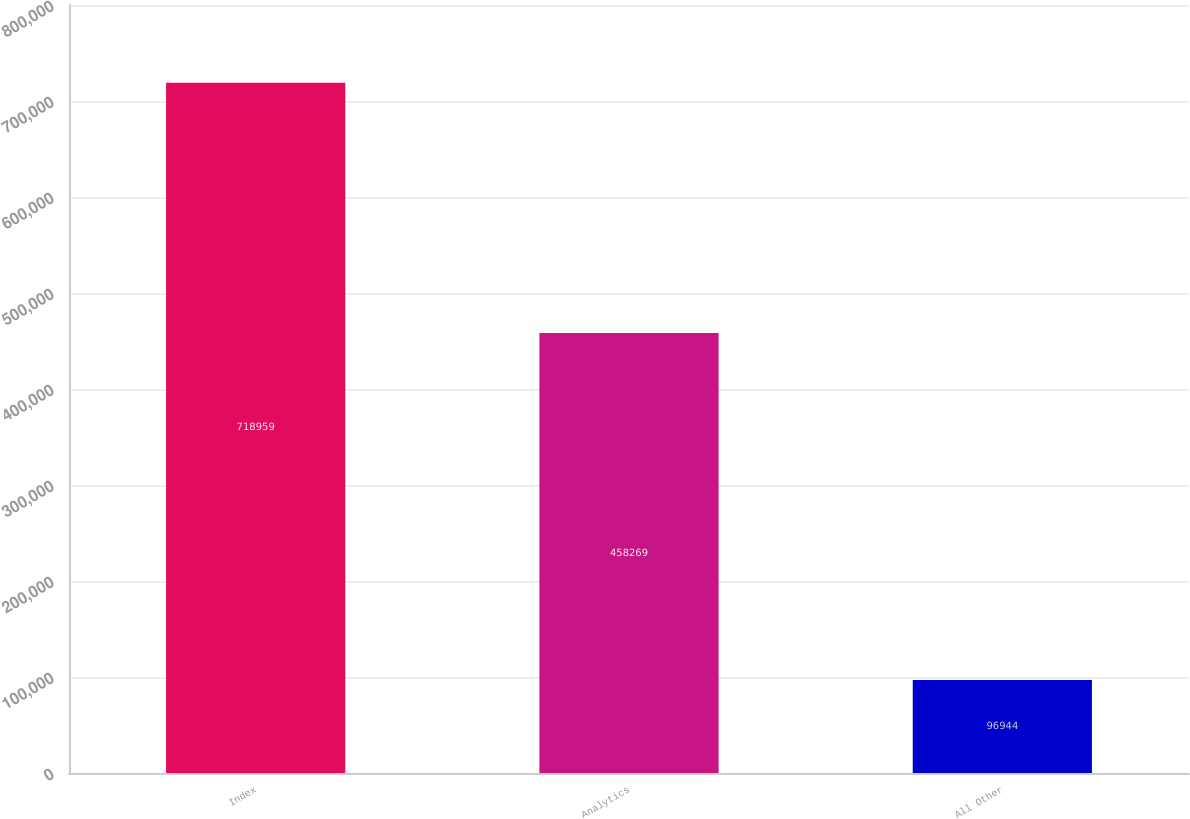Convert chart to OTSL. <chart><loc_0><loc_0><loc_500><loc_500><bar_chart><fcel>Index<fcel>Analytics<fcel>All Other<nl><fcel>718959<fcel>458269<fcel>96944<nl></chart> 